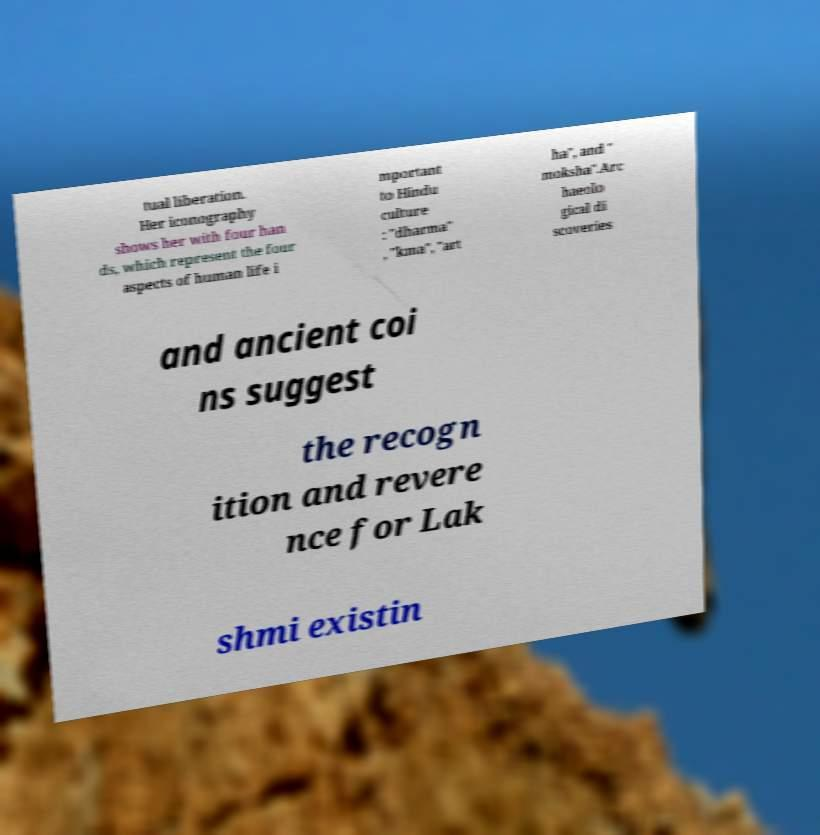Could you extract and type out the text from this image? tual liberation. Her iconography shows her with four han ds, which represent the four aspects of human life i mportant to Hindu culture : "dharma" , "kma", "art ha", and " moksha".Arc haeolo gical di scoveries and ancient coi ns suggest the recogn ition and revere nce for Lak shmi existin 